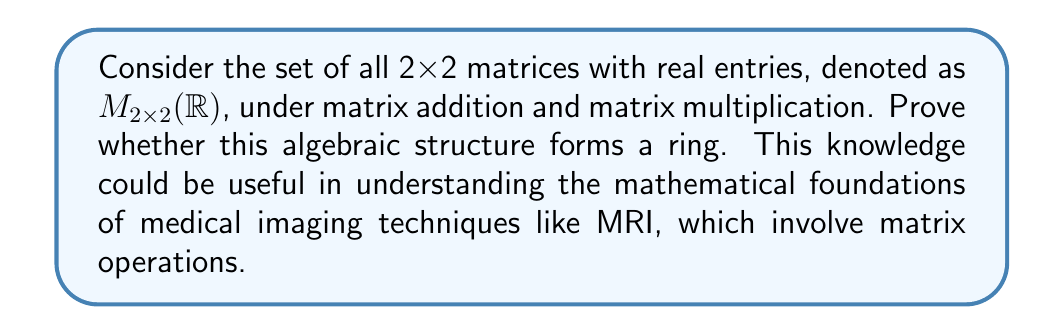Help me with this question. To prove that $M_{2\times2}(\mathbb{R})$ is a ring, we need to show that it satisfies all the ring axioms:

1. Closure under addition and multiplication
2. Associativity of addition and multiplication
3. Commutativity of addition
4. Existence of additive identity
5. Existence of additive inverse for each element
6. Distributivity of multiplication over addition

Let's verify each axiom:

1. Closure:
   - For any two 2x2 matrices $A$ and $B$, $A+B$ and $AB$ are also 2x2 matrices.

2. Associativity:
   - Addition: $(A+B)+C = A+(B+C)$ for all $A,B,C \in M_{2\times2}(\mathbb{R})$
   - Multiplication: $(AB)C = A(BC)$ for all $A,B,C \in M_{2\times2}(\mathbb{R})$

3. Commutativity of addition:
   - $A+B = B+A$ for all $A,B \in M_{2\times2}(\mathbb{R})$

4. Additive identity:
   - The zero matrix $O = \begin{pmatrix} 0 & 0 \\ 0 & 0 \end{pmatrix}$ serves as the additive identity.

5. Additive inverse:
   - For any matrix $A = \begin{pmatrix} a & b \\ c & d \end{pmatrix}$, its additive inverse is $-A = \begin{pmatrix} -a & -b \\ -c & -d \end{pmatrix}$

6. Distributivity:
   - Left distributivity: $A(B+C) = AB + AC$
   - Right distributivity: $(B+C)A = BA + CA$

All these properties hold for 2x2 matrices with real entries under standard matrix operations.

Note: Commutativity of multiplication is not required for a ring. In fact, matrix multiplication is not commutative in general, which is why $M_{2\times2}(\mathbb{R})$ is called a non-commutative ring.
Answer: $M_{2\times2}(\mathbb{R})$ forms a ring under matrix addition and multiplication, as it satisfies all the required ring axioms. 